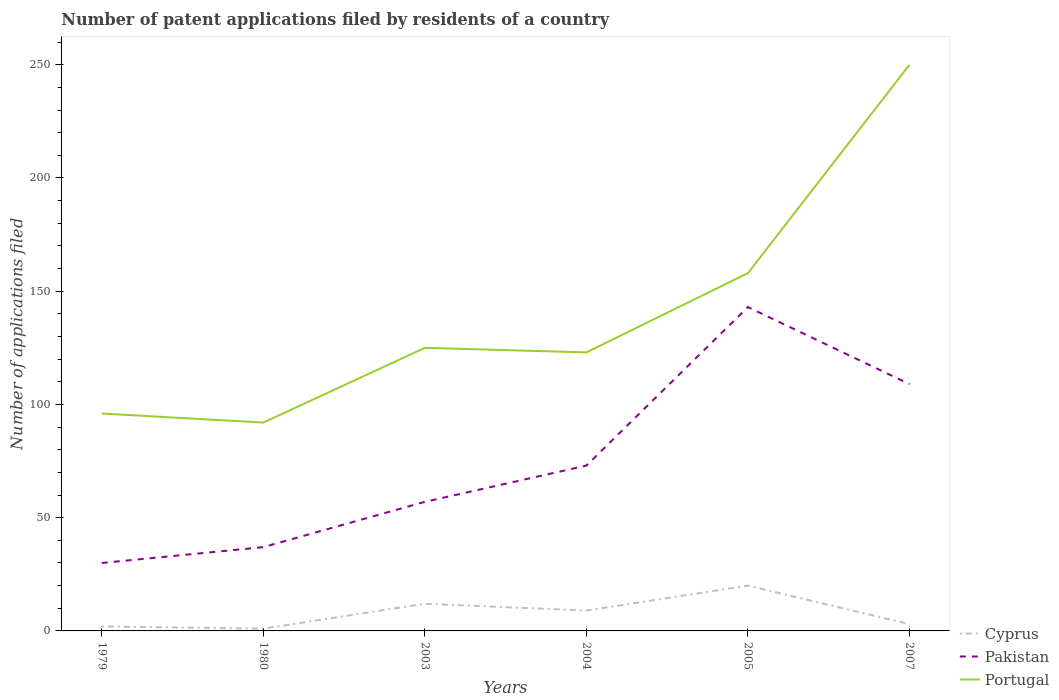How many different coloured lines are there?
Offer a very short reply. 3. Does the line corresponding to Pakistan intersect with the line corresponding to Portugal?
Your answer should be compact. No. Is the number of lines equal to the number of legend labels?
Keep it short and to the point. Yes. Across all years, what is the maximum number of applications filed in Portugal?
Give a very brief answer. 92. In which year was the number of applications filed in Portugal maximum?
Offer a terse response. 1980. What is the total number of applications filed in Pakistan in the graph?
Make the answer very short. -16. What is the difference between the highest and the second highest number of applications filed in Portugal?
Offer a very short reply. 158. What is the difference between the highest and the lowest number of applications filed in Cyprus?
Provide a succinct answer. 3. Is the number of applications filed in Pakistan strictly greater than the number of applications filed in Portugal over the years?
Your response must be concise. Yes. What is the difference between two consecutive major ticks on the Y-axis?
Your answer should be very brief. 50. Are the values on the major ticks of Y-axis written in scientific E-notation?
Ensure brevity in your answer.  No. Where does the legend appear in the graph?
Keep it short and to the point. Bottom right. How many legend labels are there?
Provide a succinct answer. 3. What is the title of the graph?
Make the answer very short. Number of patent applications filed by residents of a country. What is the label or title of the Y-axis?
Your response must be concise. Number of applications filed. What is the Number of applications filed in Pakistan in 1979?
Make the answer very short. 30. What is the Number of applications filed of Portugal in 1979?
Offer a terse response. 96. What is the Number of applications filed of Pakistan in 1980?
Offer a terse response. 37. What is the Number of applications filed in Portugal in 1980?
Ensure brevity in your answer.  92. What is the Number of applications filed of Pakistan in 2003?
Your response must be concise. 57. What is the Number of applications filed in Portugal in 2003?
Your response must be concise. 125. What is the Number of applications filed of Cyprus in 2004?
Your answer should be very brief. 9. What is the Number of applications filed of Pakistan in 2004?
Make the answer very short. 73. What is the Number of applications filed of Portugal in 2004?
Keep it short and to the point. 123. What is the Number of applications filed of Cyprus in 2005?
Keep it short and to the point. 20. What is the Number of applications filed in Pakistan in 2005?
Offer a very short reply. 143. What is the Number of applications filed in Portugal in 2005?
Provide a short and direct response. 158. What is the Number of applications filed of Cyprus in 2007?
Offer a terse response. 3. What is the Number of applications filed in Pakistan in 2007?
Provide a short and direct response. 109. What is the Number of applications filed in Portugal in 2007?
Make the answer very short. 250. Across all years, what is the maximum Number of applications filed in Pakistan?
Offer a terse response. 143. Across all years, what is the maximum Number of applications filed of Portugal?
Make the answer very short. 250. Across all years, what is the minimum Number of applications filed in Portugal?
Give a very brief answer. 92. What is the total Number of applications filed of Cyprus in the graph?
Make the answer very short. 47. What is the total Number of applications filed in Pakistan in the graph?
Keep it short and to the point. 449. What is the total Number of applications filed in Portugal in the graph?
Give a very brief answer. 844. What is the difference between the Number of applications filed in Cyprus in 1979 and that in 1980?
Ensure brevity in your answer.  1. What is the difference between the Number of applications filed in Portugal in 1979 and that in 1980?
Provide a succinct answer. 4. What is the difference between the Number of applications filed of Cyprus in 1979 and that in 2003?
Keep it short and to the point. -10. What is the difference between the Number of applications filed of Pakistan in 1979 and that in 2003?
Your response must be concise. -27. What is the difference between the Number of applications filed in Pakistan in 1979 and that in 2004?
Offer a terse response. -43. What is the difference between the Number of applications filed of Portugal in 1979 and that in 2004?
Offer a terse response. -27. What is the difference between the Number of applications filed of Pakistan in 1979 and that in 2005?
Your response must be concise. -113. What is the difference between the Number of applications filed of Portugal in 1979 and that in 2005?
Make the answer very short. -62. What is the difference between the Number of applications filed of Cyprus in 1979 and that in 2007?
Your answer should be very brief. -1. What is the difference between the Number of applications filed of Pakistan in 1979 and that in 2007?
Your response must be concise. -79. What is the difference between the Number of applications filed of Portugal in 1979 and that in 2007?
Offer a terse response. -154. What is the difference between the Number of applications filed in Pakistan in 1980 and that in 2003?
Provide a succinct answer. -20. What is the difference between the Number of applications filed in Portugal in 1980 and that in 2003?
Your answer should be compact. -33. What is the difference between the Number of applications filed of Cyprus in 1980 and that in 2004?
Provide a short and direct response. -8. What is the difference between the Number of applications filed of Pakistan in 1980 and that in 2004?
Offer a very short reply. -36. What is the difference between the Number of applications filed of Portugal in 1980 and that in 2004?
Your answer should be very brief. -31. What is the difference between the Number of applications filed of Pakistan in 1980 and that in 2005?
Your answer should be very brief. -106. What is the difference between the Number of applications filed in Portugal in 1980 and that in 2005?
Ensure brevity in your answer.  -66. What is the difference between the Number of applications filed in Pakistan in 1980 and that in 2007?
Keep it short and to the point. -72. What is the difference between the Number of applications filed in Portugal in 1980 and that in 2007?
Make the answer very short. -158. What is the difference between the Number of applications filed in Cyprus in 2003 and that in 2004?
Offer a very short reply. 3. What is the difference between the Number of applications filed of Pakistan in 2003 and that in 2004?
Offer a very short reply. -16. What is the difference between the Number of applications filed in Portugal in 2003 and that in 2004?
Your answer should be very brief. 2. What is the difference between the Number of applications filed in Pakistan in 2003 and that in 2005?
Keep it short and to the point. -86. What is the difference between the Number of applications filed in Portugal in 2003 and that in 2005?
Give a very brief answer. -33. What is the difference between the Number of applications filed in Pakistan in 2003 and that in 2007?
Provide a short and direct response. -52. What is the difference between the Number of applications filed in Portugal in 2003 and that in 2007?
Offer a very short reply. -125. What is the difference between the Number of applications filed in Cyprus in 2004 and that in 2005?
Your response must be concise. -11. What is the difference between the Number of applications filed of Pakistan in 2004 and that in 2005?
Keep it short and to the point. -70. What is the difference between the Number of applications filed in Portugal in 2004 and that in 2005?
Your answer should be compact. -35. What is the difference between the Number of applications filed of Pakistan in 2004 and that in 2007?
Provide a succinct answer. -36. What is the difference between the Number of applications filed of Portugal in 2004 and that in 2007?
Give a very brief answer. -127. What is the difference between the Number of applications filed of Cyprus in 2005 and that in 2007?
Provide a short and direct response. 17. What is the difference between the Number of applications filed in Portugal in 2005 and that in 2007?
Your answer should be very brief. -92. What is the difference between the Number of applications filed of Cyprus in 1979 and the Number of applications filed of Pakistan in 1980?
Offer a very short reply. -35. What is the difference between the Number of applications filed in Cyprus in 1979 and the Number of applications filed in Portugal in 1980?
Keep it short and to the point. -90. What is the difference between the Number of applications filed in Pakistan in 1979 and the Number of applications filed in Portugal in 1980?
Offer a terse response. -62. What is the difference between the Number of applications filed of Cyprus in 1979 and the Number of applications filed of Pakistan in 2003?
Offer a terse response. -55. What is the difference between the Number of applications filed of Cyprus in 1979 and the Number of applications filed of Portugal in 2003?
Make the answer very short. -123. What is the difference between the Number of applications filed in Pakistan in 1979 and the Number of applications filed in Portugal in 2003?
Offer a terse response. -95. What is the difference between the Number of applications filed in Cyprus in 1979 and the Number of applications filed in Pakistan in 2004?
Your response must be concise. -71. What is the difference between the Number of applications filed in Cyprus in 1979 and the Number of applications filed in Portugal in 2004?
Your response must be concise. -121. What is the difference between the Number of applications filed in Pakistan in 1979 and the Number of applications filed in Portugal in 2004?
Give a very brief answer. -93. What is the difference between the Number of applications filed in Cyprus in 1979 and the Number of applications filed in Pakistan in 2005?
Your answer should be very brief. -141. What is the difference between the Number of applications filed in Cyprus in 1979 and the Number of applications filed in Portugal in 2005?
Make the answer very short. -156. What is the difference between the Number of applications filed in Pakistan in 1979 and the Number of applications filed in Portugal in 2005?
Your answer should be compact. -128. What is the difference between the Number of applications filed in Cyprus in 1979 and the Number of applications filed in Pakistan in 2007?
Your answer should be very brief. -107. What is the difference between the Number of applications filed of Cyprus in 1979 and the Number of applications filed of Portugal in 2007?
Your response must be concise. -248. What is the difference between the Number of applications filed in Pakistan in 1979 and the Number of applications filed in Portugal in 2007?
Ensure brevity in your answer.  -220. What is the difference between the Number of applications filed in Cyprus in 1980 and the Number of applications filed in Pakistan in 2003?
Offer a terse response. -56. What is the difference between the Number of applications filed in Cyprus in 1980 and the Number of applications filed in Portugal in 2003?
Give a very brief answer. -124. What is the difference between the Number of applications filed in Pakistan in 1980 and the Number of applications filed in Portugal in 2003?
Your answer should be compact. -88. What is the difference between the Number of applications filed in Cyprus in 1980 and the Number of applications filed in Pakistan in 2004?
Keep it short and to the point. -72. What is the difference between the Number of applications filed of Cyprus in 1980 and the Number of applications filed of Portugal in 2004?
Give a very brief answer. -122. What is the difference between the Number of applications filed of Pakistan in 1980 and the Number of applications filed of Portugal in 2004?
Your answer should be compact. -86. What is the difference between the Number of applications filed of Cyprus in 1980 and the Number of applications filed of Pakistan in 2005?
Offer a terse response. -142. What is the difference between the Number of applications filed of Cyprus in 1980 and the Number of applications filed of Portugal in 2005?
Your response must be concise. -157. What is the difference between the Number of applications filed of Pakistan in 1980 and the Number of applications filed of Portugal in 2005?
Provide a succinct answer. -121. What is the difference between the Number of applications filed in Cyprus in 1980 and the Number of applications filed in Pakistan in 2007?
Provide a short and direct response. -108. What is the difference between the Number of applications filed in Cyprus in 1980 and the Number of applications filed in Portugal in 2007?
Keep it short and to the point. -249. What is the difference between the Number of applications filed in Pakistan in 1980 and the Number of applications filed in Portugal in 2007?
Your answer should be very brief. -213. What is the difference between the Number of applications filed of Cyprus in 2003 and the Number of applications filed of Pakistan in 2004?
Your answer should be compact. -61. What is the difference between the Number of applications filed of Cyprus in 2003 and the Number of applications filed of Portugal in 2004?
Ensure brevity in your answer.  -111. What is the difference between the Number of applications filed of Pakistan in 2003 and the Number of applications filed of Portugal in 2004?
Your response must be concise. -66. What is the difference between the Number of applications filed in Cyprus in 2003 and the Number of applications filed in Pakistan in 2005?
Your answer should be compact. -131. What is the difference between the Number of applications filed of Cyprus in 2003 and the Number of applications filed of Portugal in 2005?
Give a very brief answer. -146. What is the difference between the Number of applications filed of Pakistan in 2003 and the Number of applications filed of Portugal in 2005?
Keep it short and to the point. -101. What is the difference between the Number of applications filed of Cyprus in 2003 and the Number of applications filed of Pakistan in 2007?
Give a very brief answer. -97. What is the difference between the Number of applications filed in Cyprus in 2003 and the Number of applications filed in Portugal in 2007?
Ensure brevity in your answer.  -238. What is the difference between the Number of applications filed of Pakistan in 2003 and the Number of applications filed of Portugal in 2007?
Provide a short and direct response. -193. What is the difference between the Number of applications filed of Cyprus in 2004 and the Number of applications filed of Pakistan in 2005?
Ensure brevity in your answer.  -134. What is the difference between the Number of applications filed of Cyprus in 2004 and the Number of applications filed of Portugal in 2005?
Offer a terse response. -149. What is the difference between the Number of applications filed in Pakistan in 2004 and the Number of applications filed in Portugal in 2005?
Keep it short and to the point. -85. What is the difference between the Number of applications filed of Cyprus in 2004 and the Number of applications filed of Pakistan in 2007?
Provide a short and direct response. -100. What is the difference between the Number of applications filed in Cyprus in 2004 and the Number of applications filed in Portugal in 2007?
Your answer should be compact. -241. What is the difference between the Number of applications filed in Pakistan in 2004 and the Number of applications filed in Portugal in 2007?
Offer a very short reply. -177. What is the difference between the Number of applications filed of Cyprus in 2005 and the Number of applications filed of Pakistan in 2007?
Provide a short and direct response. -89. What is the difference between the Number of applications filed of Cyprus in 2005 and the Number of applications filed of Portugal in 2007?
Offer a very short reply. -230. What is the difference between the Number of applications filed in Pakistan in 2005 and the Number of applications filed in Portugal in 2007?
Your answer should be very brief. -107. What is the average Number of applications filed in Cyprus per year?
Provide a short and direct response. 7.83. What is the average Number of applications filed in Pakistan per year?
Keep it short and to the point. 74.83. What is the average Number of applications filed in Portugal per year?
Offer a terse response. 140.67. In the year 1979, what is the difference between the Number of applications filed of Cyprus and Number of applications filed of Pakistan?
Ensure brevity in your answer.  -28. In the year 1979, what is the difference between the Number of applications filed in Cyprus and Number of applications filed in Portugal?
Offer a terse response. -94. In the year 1979, what is the difference between the Number of applications filed of Pakistan and Number of applications filed of Portugal?
Make the answer very short. -66. In the year 1980, what is the difference between the Number of applications filed in Cyprus and Number of applications filed in Pakistan?
Your answer should be very brief. -36. In the year 1980, what is the difference between the Number of applications filed of Cyprus and Number of applications filed of Portugal?
Ensure brevity in your answer.  -91. In the year 1980, what is the difference between the Number of applications filed of Pakistan and Number of applications filed of Portugal?
Provide a short and direct response. -55. In the year 2003, what is the difference between the Number of applications filed of Cyprus and Number of applications filed of Pakistan?
Offer a terse response. -45. In the year 2003, what is the difference between the Number of applications filed in Cyprus and Number of applications filed in Portugal?
Give a very brief answer. -113. In the year 2003, what is the difference between the Number of applications filed in Pakistan and Number of applications filed in Portugal?
Your answer should be very brief. -68. In the year 2004, what is the difference between the Number of applications filed in Cyprus and Number of applications filed in Pakistan?
Your answer should be compact. -64. In the year 2004, what is the difference between the Number of applications filed in Cyprus and Number of applications filed in Portugal?
Offer a terse response. -114. In the year 2005, what is the difference between the Number of applications filed in Cyprus and Number of applications filed in Pakistan?
Provide a succinct answer. -123. In the year 2005, what is the difference between the Number of applications filed of Cyprus and Number of applications filed of Portugal?
Your answer should be compact. -138. In the year 2007, what is the difference between the Number of applications filed of Cyprus and Number of applications filed of Pakistan?
Offer a terse response. -106. In the year 2007, what is the difference between the Number of applications filed in Cyprus and Number of applications filed in Portugal?
Your answer should be very brief. -247. In the year 2007, what is the difference between the Number of applications filed in Pakistan and Number of applications filed in Portugal?
Your answer should be very brief. -141. What is the ratio of the Number of applications filed in Cyprus in 1979 to that in 1980?
Give a very brief answer. 2. What is the ratio of the Number of applications filed of Pakistan in 1979 to that in 1980?
Offer a terse response. 0.81. What is the ratio of the Number of applications filed in Portugal in 1979 to that in 1980?
Give a very brief answer. 1.04. What is the ratio of the Number of applications filed in Cyprus in 1979 to that in 2003?
Your answer should be very brief. 0.17. What is the ratio of the Number of applications filed in Pakistan in 1979 to that in 2003?
Offer a terse response. 0.53. What is the ratio of the Number of applications filed of Portugal in 1979 to that in 2003?
Offer a terse response. 0.77. What is the ratio of the Number of applications filed in Cyprus in 1979 to that in 2004?
Make the answer very short. 0.22. What is the ratio of the Number of applications filed in Pakistan in 1979 to that in 2004?
Your answer should be compact. 0.41. What is the ratio of the Number of applications filed of Portugal in 1979 to that in 2004?
Your answer should be very brief. 0.78. What is the ratio of the Number of applications filed in Pakistan in 1979 to that in 2005?
Your response must be concise. 0.21. What is the ratio of the Number of applications filed of Portugal in 1979 to that in 2005?
Provide a succinct answer. 0.61. What is the ratio of the Number of applications filed in Cyprus in 1979 to that in 2007?
Your answer should be compact. 0.67. What is the ratio of the Number of applications filed of Pakistan in 1979 to that in 2007?
Your answer should be very brief. 0.28. What is the ratio of the Number of applications filed in Portugal in 1979 to that in 2007?
Provide a short and direct response. 0.38. What is the ratio of the Number of applications filed in Cyprus in 1980 to that in 2003?
Your response must be concise. 0.08. What is the ratio of the Number of applications filed of Pakistan in 1980 to that in 2003?
Your response must be concise. 0.65. What is the ratio of the Number of applications filed in Portugal in 1980 to that in 2003?
Make the answer very short. 0.74. What is the ratio of the Number of applications filed in Pakistan in 1980 to that in 2004?
Keep it short and to the point. 0.51. What is the ratio of the Number of applications filed in Portugal in 1980 to that in 2004?
Offer a terse response. 0.75. What is the ratio of the Number of applications filed in Pakistan in 1980 to that in 2005?
Your answer should be very brief. 0.26. What is the ratio of the Number of applications filed of Portugal in 1980 to that in 2005?
Ensure brevity in your answer.  0.58. What is the ratio of the Number of applications filed of Cyprus in 1980 to that in 2007?
Your response must be concise. 0.33. What is the ratio of the Number of applications filed in Pakistan in 1980 to that in 2007?
Make the answer very short. 0.34. What is the ratio of the Number of applications filed of Portugal in 1980 to that in 2007?
Offer a terse response. 0.37. What is the ratio of the Number of applications filed in Pakistan in 2003 to that in 2004?
Ensure brevity in your answer.  0.78. What is the ratio of the Number of applications filed in Portugal in 2003 to that in 2004?
Offer a terse response. 1.02. What is the ratio of the Number of applications filed of Pakistan in 2003 to that in 2005?
Offer a very short reply. 0.4. What is the ratio of the Number of applications filed in Portugal in 2003 to that in 2005?
Keep it short and to the point. 0.79. What is the ratio of the Number of applications filed of Cyprus in 2003 to that in 2007?
Your response must be concise. 4. What is the ratio of the Number of applications filed of Pakistan in 2003 to that in 2007?
Ensure brevity in your answer.  0.52. What is the ratio of the Number of applications filed in Portugal in 2003 to that in 2007?
Give a very brief answer. 0.5. What is the ratio of the Number of applications filed of Cyprus in 2004 to that in 2005?
Make the answer very short. 0.45. What is the ratio of the Number of applications filed in Pakistan in 2004 to that in 2005?
Offer a very short reply. 0.51. What is the ratio of the Number of applications filed of Portugal in 2004 to that in 2005?
Ensure brevity in your answer.  0.78. What is the ratio of the Number of applications filed in Pakistan in 2004 to that in 2007?
Offer a terse response. 0.67. What is the ratio of the Number of applications filed in Portugal in 2004 to that in 2007?
Give a very brief answer. 0.49. What is the ratio of the Number of applications filed in Cyprus in 2005 to that in 2007?
Make the answer very short. 6.67. What is the ratio of the Number of applications filed in Pakistan in 2005 to that in 2007?
Provide a succinct answer. 1.31. What is the ratio of the Number of applications filed of Portugal in 2005 to that in 2007?
Give a very brief answer. 0.63. What is the difference between the highest and the second highest Number of applications filed in Pakistan?
Your answer should be very brief. 34. What is the difference between the highest and the second highest Number of applications filed in Portugal?
Your answer should be very brief. 92. What is the difference between the highest and the lowest Number of applications filed of Cyprus?
Offer a very short reply. 19. What is the difference between the highest and the lowest Number of applications filed of Pakistan?
Offer a terse response. 113. What is the difference between the highest and the lowest Number of applications filed of Portugal?
Give a very brief answer. 158. 